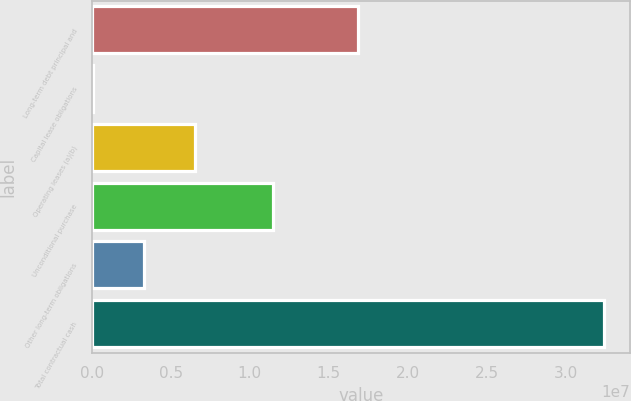Convert chart. <chart><loc_0><loc_0><loc_500><loc_500><bar_chart><fcel>Long-term debt principal and<fcel>Capital lease obligations<fcel>Operating leases (a)(b)<fcel>Unconditional purchase<fcel>Other long-term obligations<fcel>Total contractual cash<nl><fcel>1.68555e+07<fcel>79811<fcel>6.55717e+06<fcel>1.14569e+07<fcel>3.31849e+06<fcel>3.24666e+07<nl></chart> 